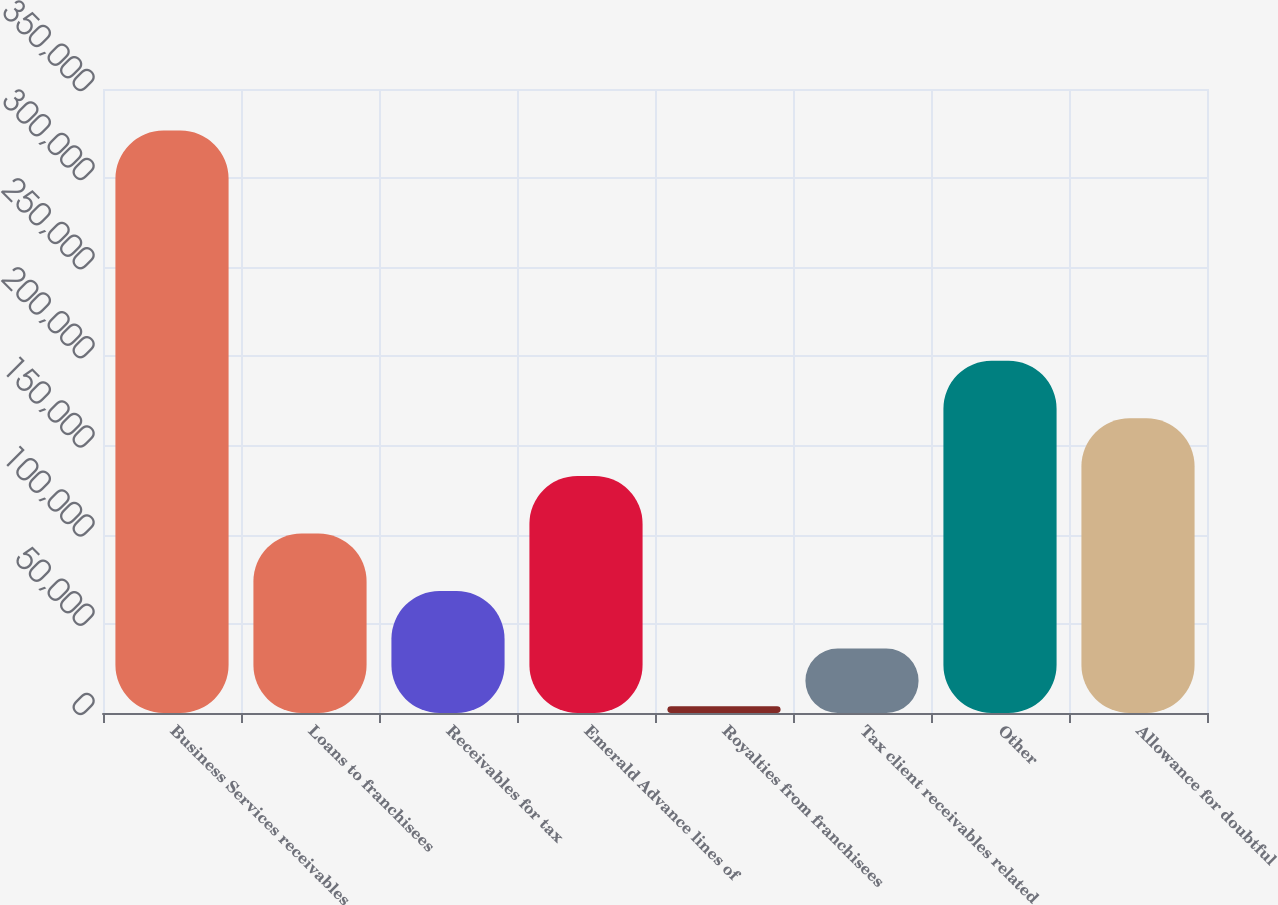Convert chart. <chart><loc_0><loc_0><loc_500><loc_500><bar_chart><fcel>Business Services receivables<fcel>Loans to franchisees<fcel>Receivables for tax<fcel>Emerald Advance lines of<fcel>Royalties from franchisees<fcel>Tax client receivables related<fcel>Other<fcel>Allowance for doubtful<nl><fcel>326681<fcel>100696<fcel>68412.2<fcel>132979<fcel>3845<fcel>36128.6<fcel>197547<fcel>165263<nl></chart> 